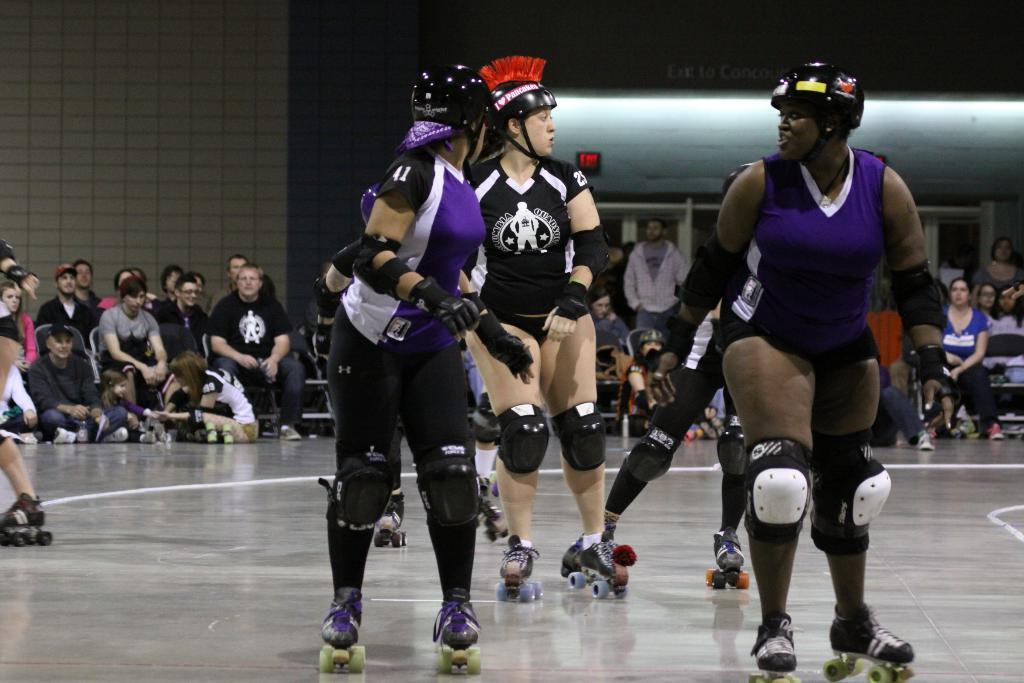What are the people in the image doing? The people in the image are skating on the floor. Can you describe the people in the background of the image? There are people sitting in the background of the image. What is on the wall in the image? There is a wall with text written on it in the image. How many horses are present in the image? There are no horses present in the image. What year is depicted in the image? The image does not depict a specific year; it shows people skating and sitting. 